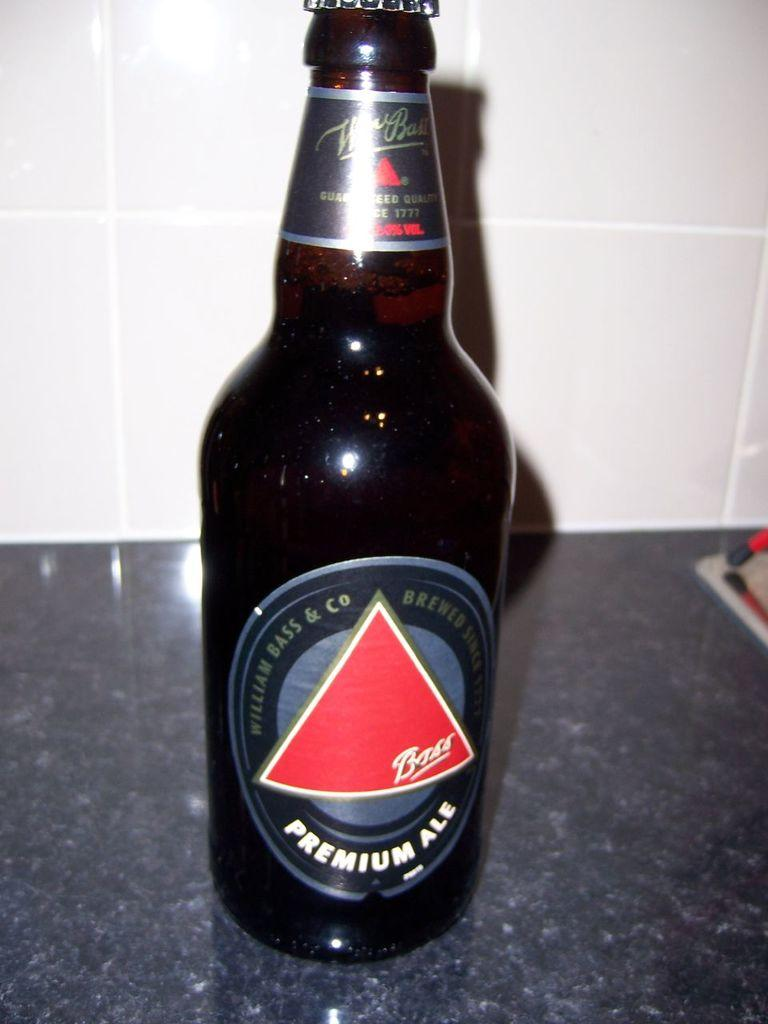<image>
Write a terse but informative summary of the picture. a bottle of Premium Ale Beer by Bass 